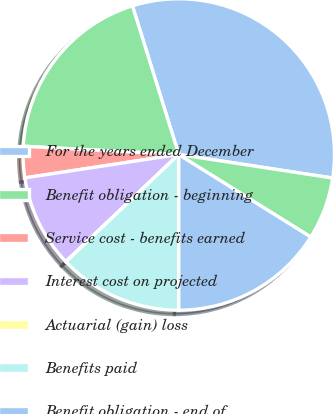Convert chart. <chart><loc_0><loc_0><loc_500><loc_500><pie_chart><fcel>For the years ended December<fcel>Benefit obligation - beginning<fcel>Service cost - benefits earned<fcel>Interest cost on projected<fcel>Actuarial (gain) loss<fcel>Benefits paid<fcel>Benefit obligation - end of<fcel>Funded/(Unfunded) status<nl><fcel>32.23%<fcel>19.35%<fcel>3.24%<fcel>9.68%<fcel>0.02%<fcel>12.9%<fcel>16.12%<fcel>6.46%<nl></chart> 